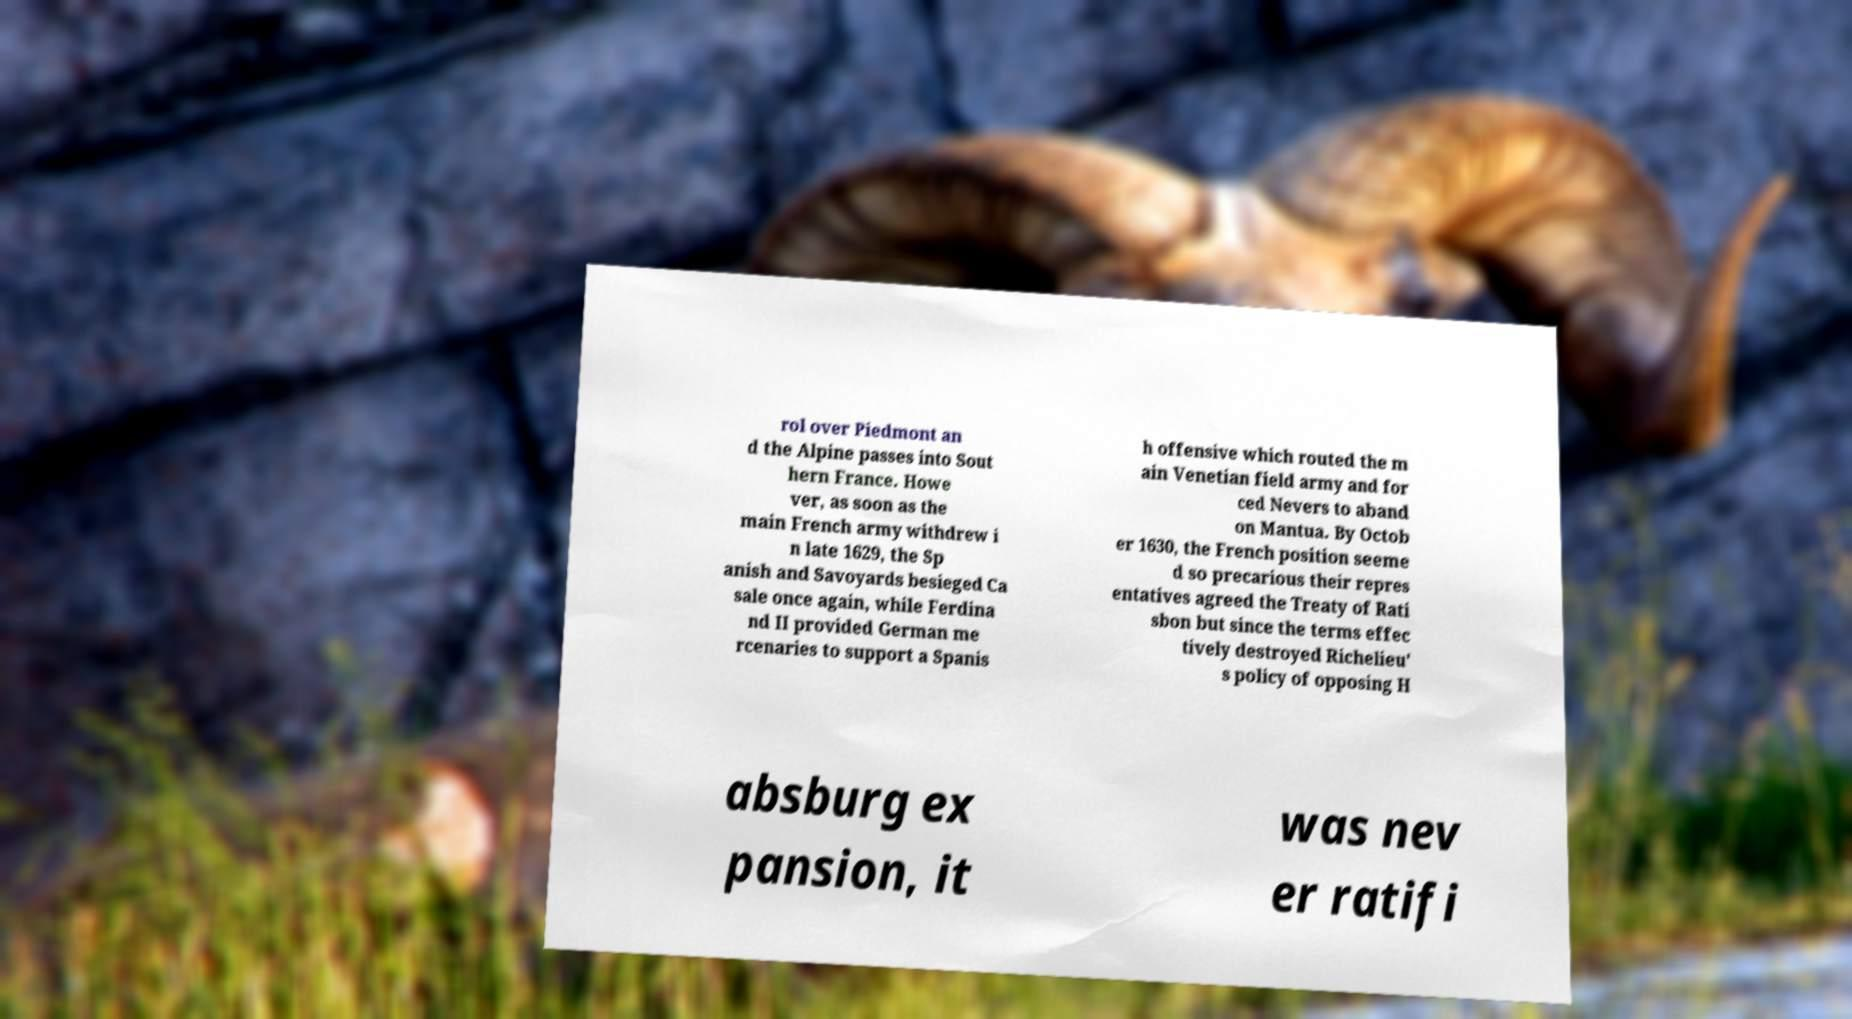Can you read and provide the text displayed in the image?This photo seems to have some interesting text. Can you extract and type it out for me? rol over Piedmont an d the Alpine passes into Sout hern France. Howe ver, as soon as the main French army withdrew i n late 1629, the Sp anish and Savoyards besieged Ca sale once again, while Ferdina nd II provided German me rcenaries to support a Spanis h offensive which routed the m ain Venetian field army and for ced Nevers to aband on Mantua. By Octob er 1630, the French position seeme d so precarious their repres entatives agreed the Treaty of Rati sbon but since the terms effec tively destroyed Richelieu' s policy of opposing H absburg ex pansion, it was nev er ratifi 